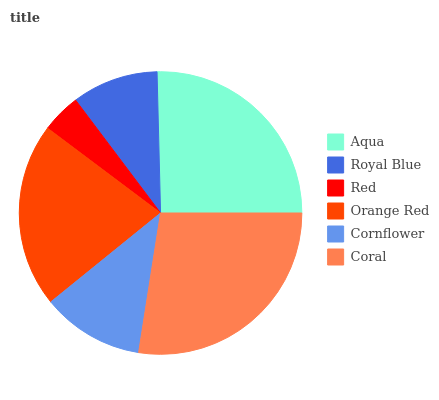Is Red the minimum?
Answer yes or no. Yes. Is Coral the maximum?
Answer yes or no. Yes. Is Royal Blue the minimum?
Answer yes or no. No. Is Royal Blue the maximum?
Answer yes or no. No. Is Aqua greater than Royal Blue?
Answer yes or no. Yes. Is Royal Blue less than Aqua?
Answer yes or no. Yes. Is Royal Blue greater than Aqua?
Answer yes or no. No. Is Aqua less than Royal Blue?
Answer yes or no. No. Is Orange Red the high median?
Answer yes or no. Yes. Is Cornflower the low median?
Answer yes or no. Yes. Is Coral the high median?
Answer yes or no. No. Is Coral the low median?
Answer yes or no. No. 